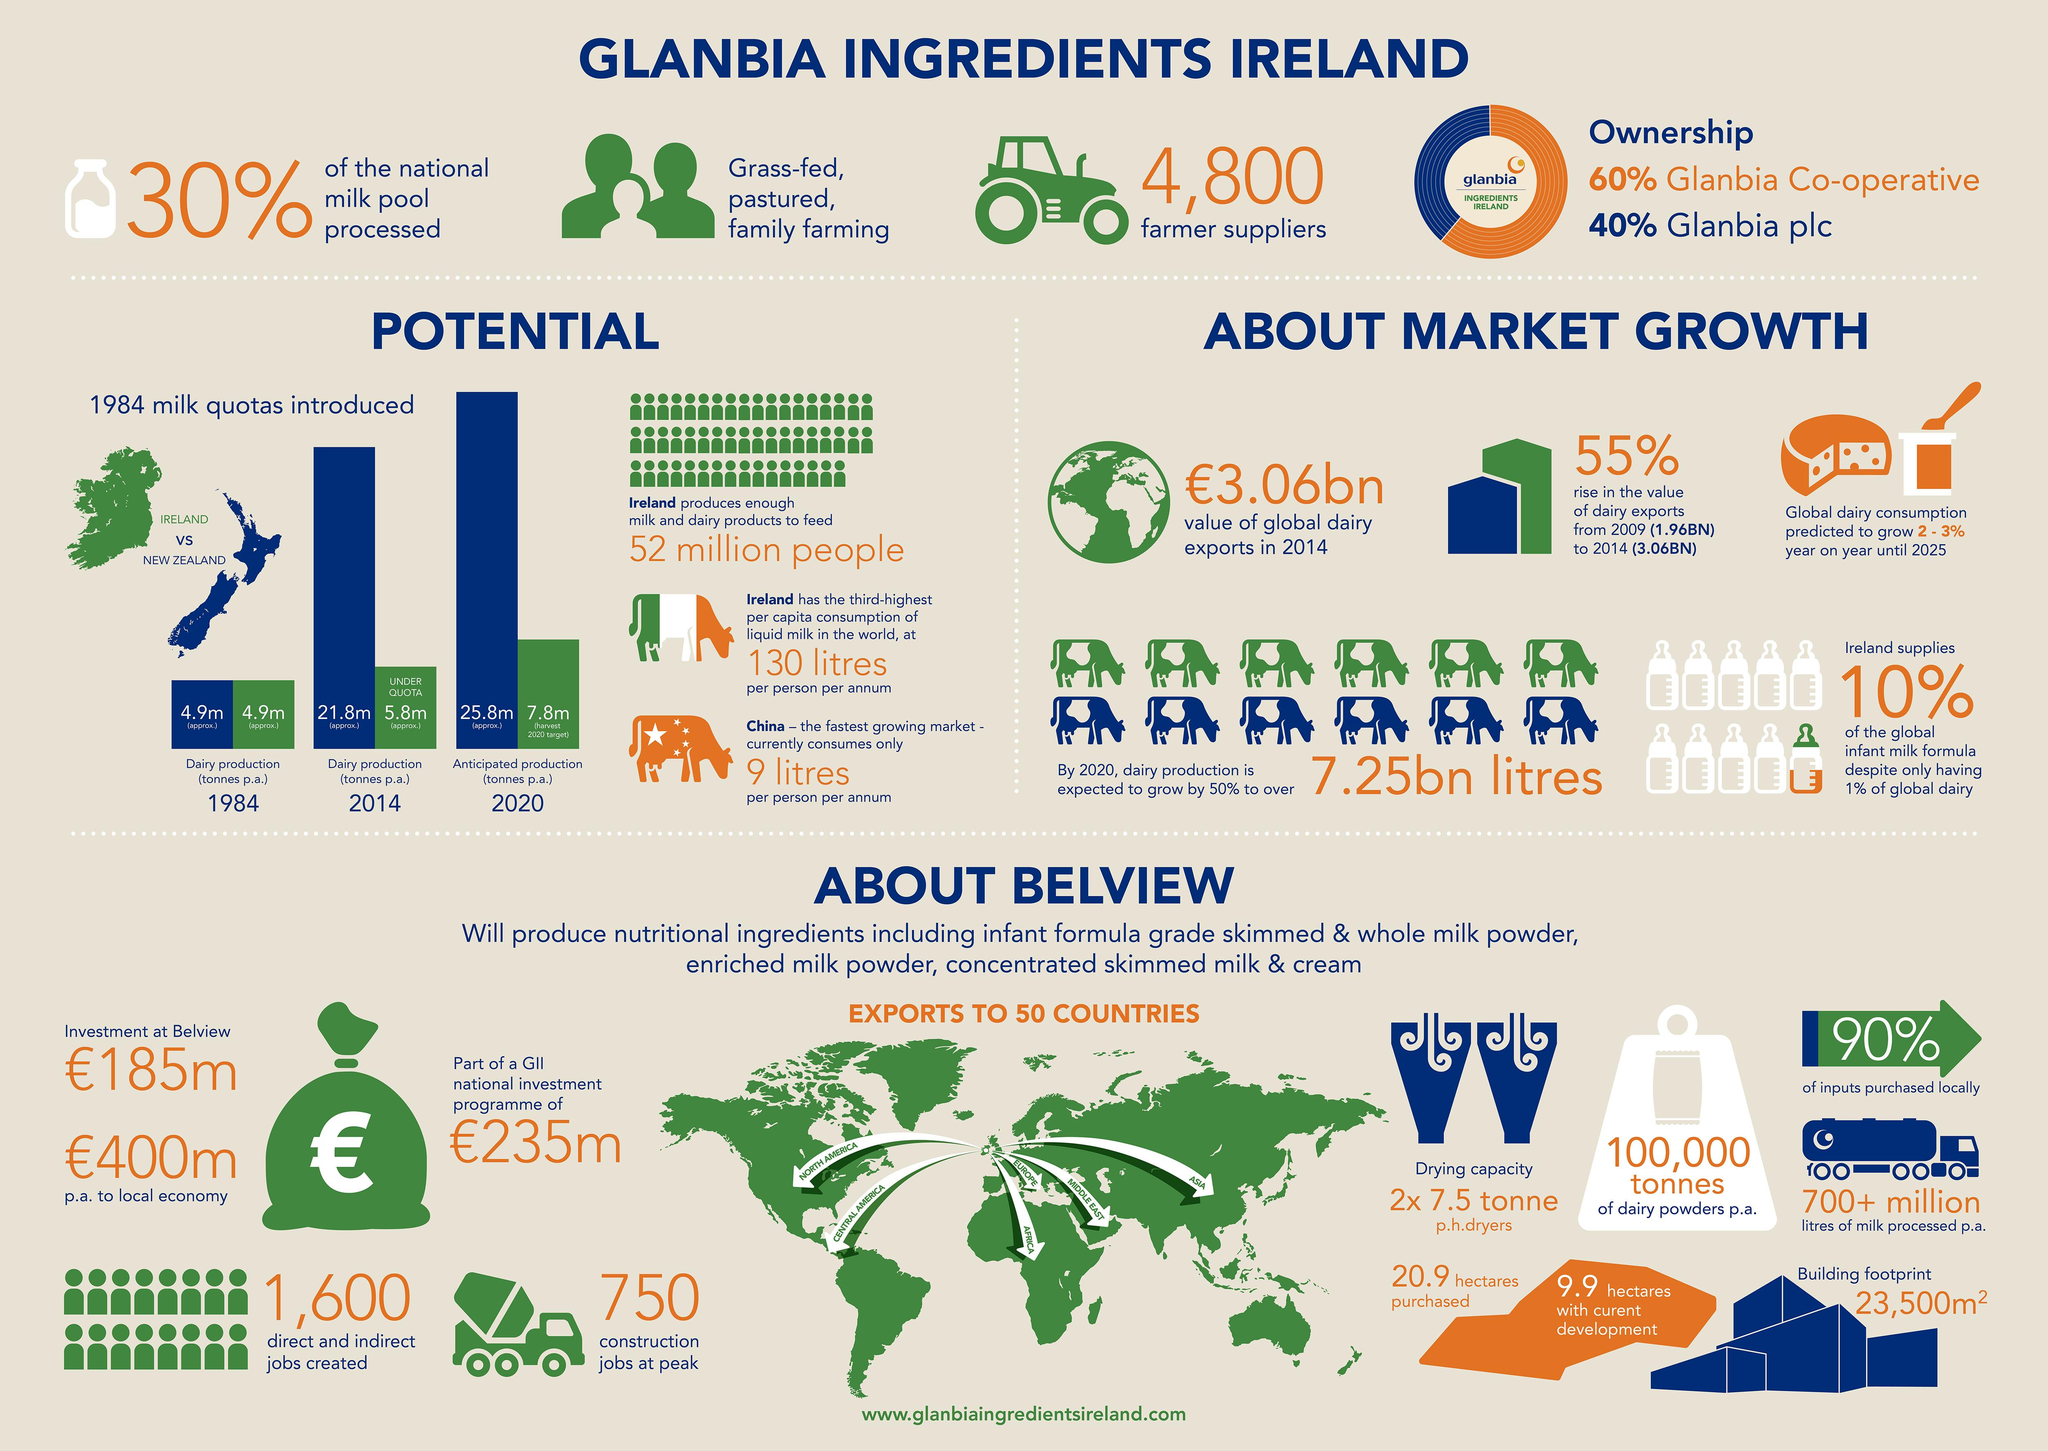List a handful of essential elements in this visual. The bar chart shows the total amount of milk produced in Ireland in 1984, which was approximately 4.9 million tonnes. According to the bar chart, the total amount of milk produced by New Zealand in 1984 was approximately 4.9 million tonnes. In 2014, New Zealand produced approximately 21.8 million tonnes of milk, as shown by the bar chart. The average amount of milk produced by New Zealand and Ireland in 2014, as per the bar chart, was approximately 13.8 million tonnes. According to the bar chart, the average milk production expected from New Zealand and Ireland in 2020 is approximately 16.8 million tonnes. 